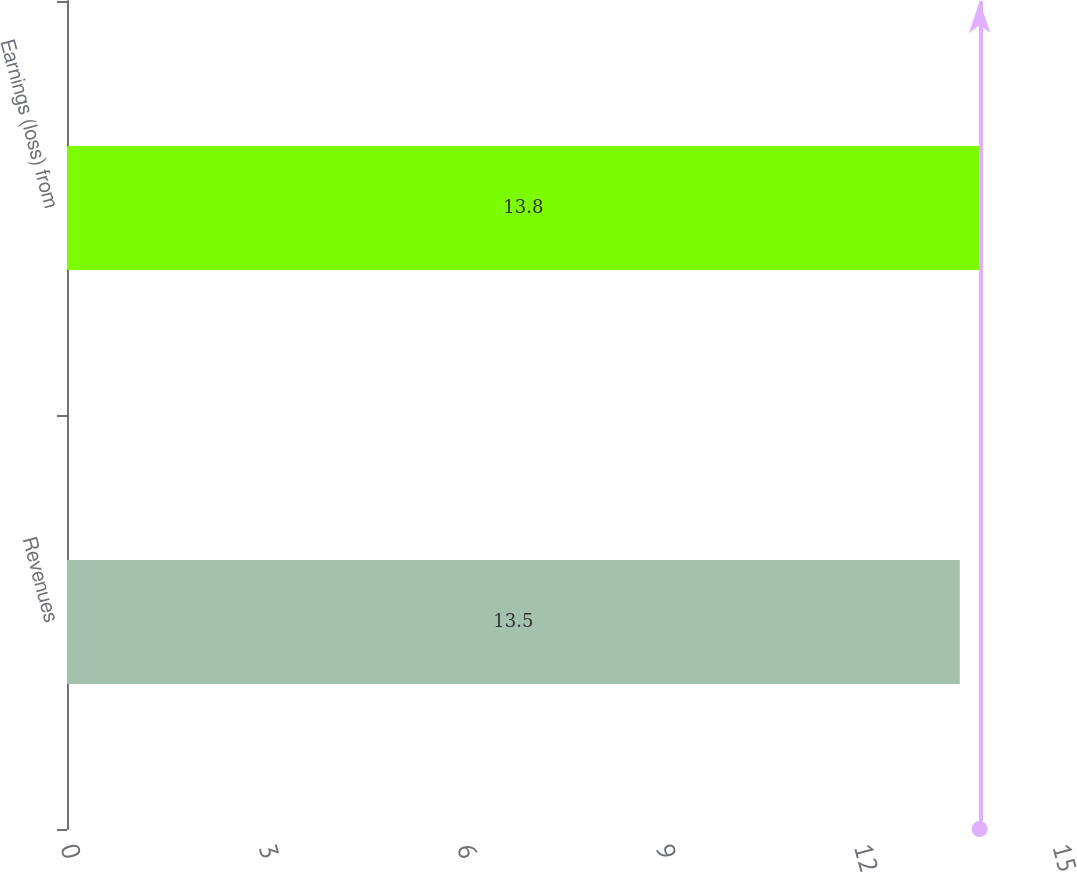Convert chart to OTSL. <chart><loc_0><loc_0><loc_500><loc_500><bar_chart><fcel>Revenues<fcel>Earnings (loss) from<nl><fcel>13.5<fcel>13.8<nl></chart> 